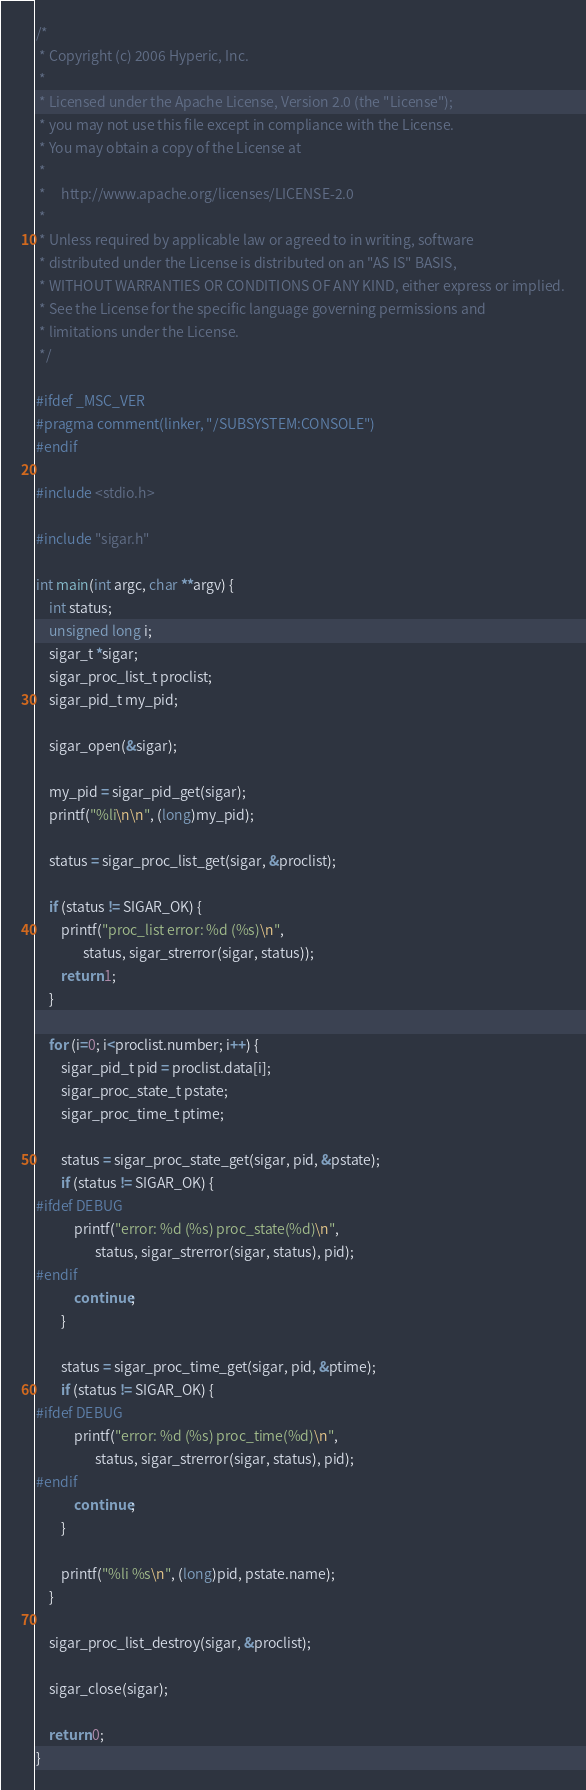<code> <loc_0><loc_0><loc_500><loc_500><_C_>/*
 * Copyright (c) 2006 Hyperic, Inc.
 *
 * Licensed under the Apache License, Version 2.0 (the "License");
 * you may not use this file except in compliance with the License.
 * You may obtain a copy of the License at
 *
 *     http://www.apache.org/licenses/LICENSE-2.0
 *
 * Unless required by applicable law or agreed to in writing, software
 * distributed under the License is distributed on an "AS IS" BASIS,
 * WITHOUT WARRANTIES OR CONDITIONS OF ANY KIND, either express or implied.
 * See the License for the specific language governing permissions and
 * limitations under the License.
 */

#ifdef _MSC_VER
#pragma comment(linker, "/SUBSYSTEM:CONSOLE")
#endif

#include <stdio.h>

#include "sigar.h"

int main(int argc, char **argv) {
    int status;
    unsigned long i;
    sigar_t *sigar;
    sigar_proc_list_t proclist;
    sigar_pid_t my_pid;

    sigar_open(&sigar);

    my_pid = sigar_pid_get(sigar);
    printf("%li\n\n", (long)my_pid);

    status = sigar_proc_list_get(sigar, &proclist);

    if (status != SIGAR_OK) {
        printf("proc_list error: %d (%s)\n",
               status, sigar_strerror(sigar, status));
        return 1;
    }

    for (i=0; i<proclist.number; i++) {
        sigar_pid_t pid = proclist.data[i];
        sigar_proc_state_t pstate;
        sigar_proc_time_t ptime;

        status = sigar_proc_state_get(sigar, pid, &pstate);
        if (status != SIGAR_OK) {
#ifdef DEBUG
            printf("error: %d (%s) proc_state(%d)\n",
                   status, sigar_strerror(sigar, status), pid);
#endif
            continue;
        }

        status = sigar_proc_time_get(sigar, pid, &ptime);
        if (status != SIGAR_OK) {
#ifdef DEBUG
            printf("error: %d (%s) proc_time(%d)\n",
                   status, sigar_strerror(sigar, status), pid);
#endif
            continue;
        }

        printf("%li %s\n", (long)pid, pstate.name);
    }

    sigar_proc_list_destroy(sigar, &proclist);

    sigar_close(sigar);

    return 0;
}
</code> 